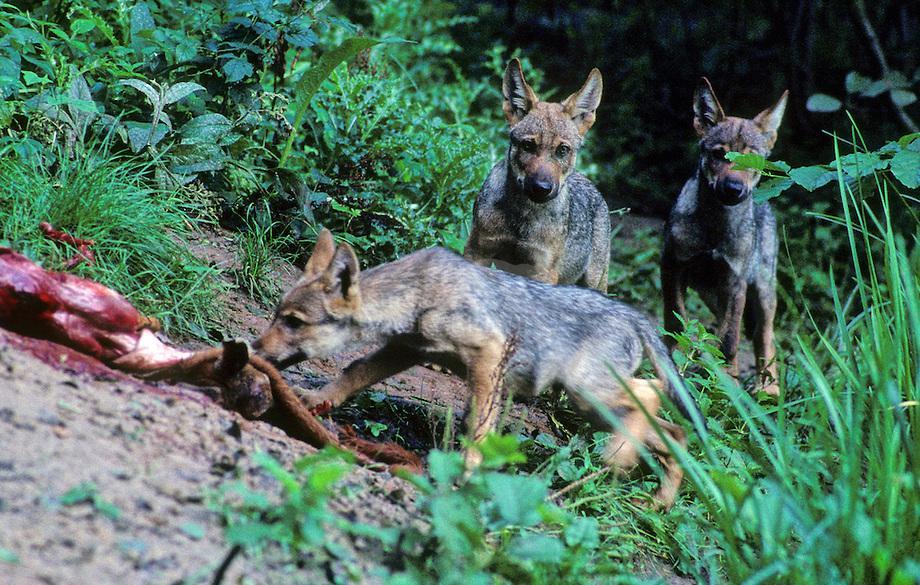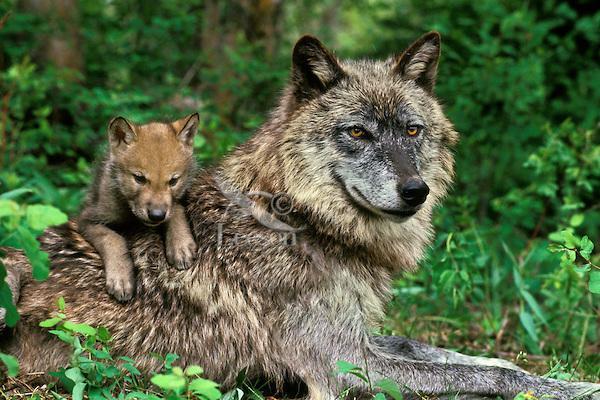The first image is the image on the left, the second image is the image on the right. For the images displayed, is the sentence "An image includes a wild dog bending down toward the carcass of an animal." factually correct? Answer yes or no. Yes. The first image is the image on the left, the second image is the image on the right. Examine the images to the left and right. Is the description "The left image contains exactly two baby wolves." accurate? Answer yes or no. No. 